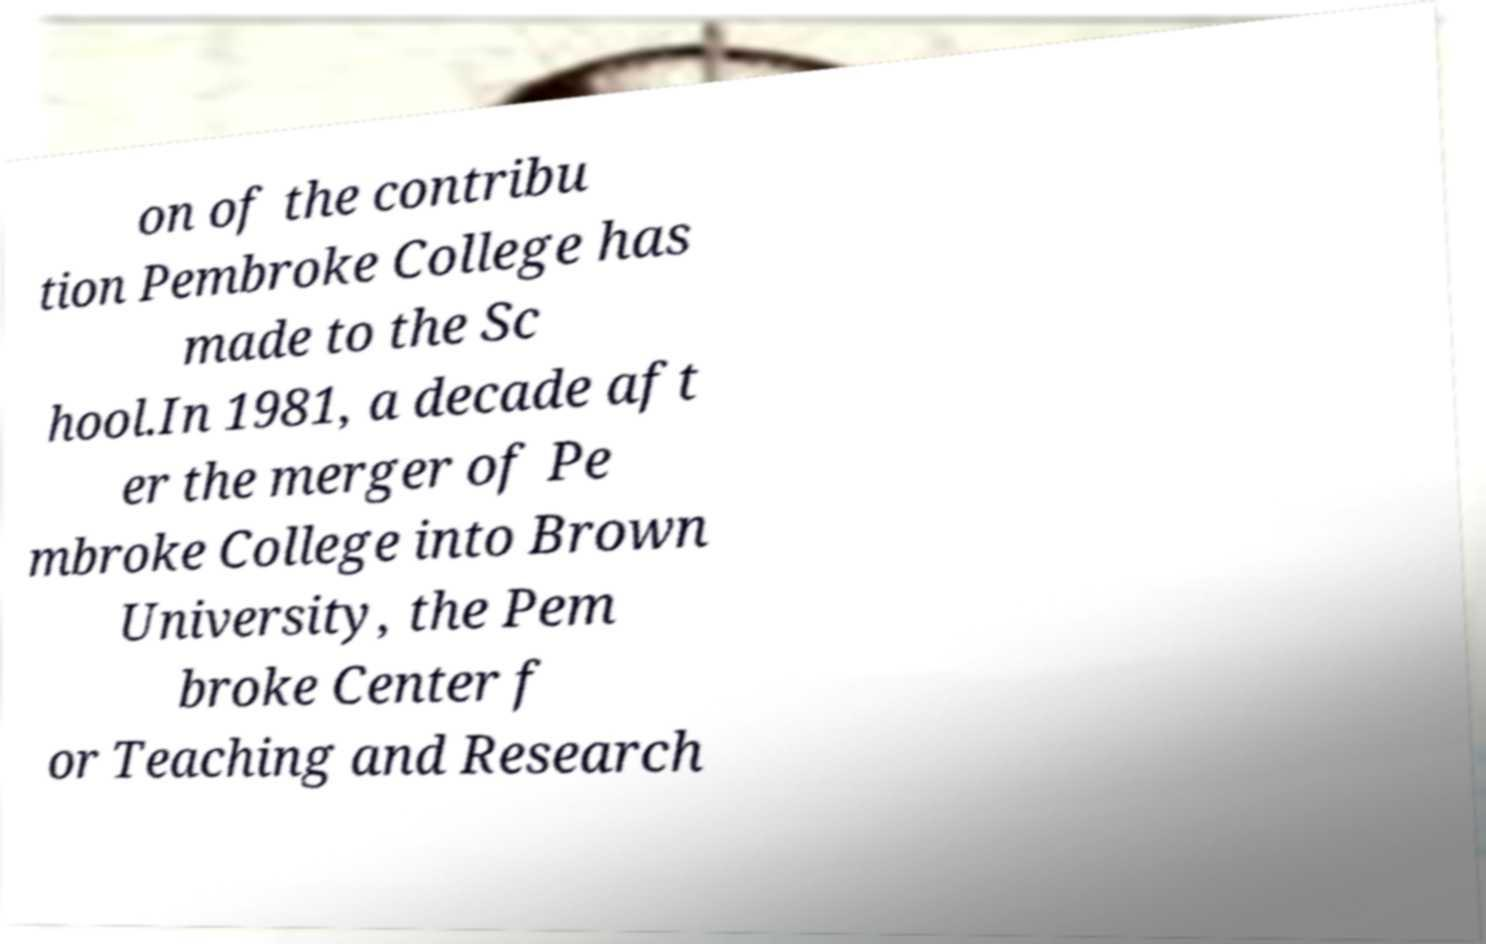There's text embedded in this image that I need extracted. Can you transcribe it verbatim? on of the contribu tion Pembroke College has made to the Sc hool.In 1981, a decade aft er the merger of Pe mbroke College into Brown University, the Pem broke Center f or Teaching and Research 